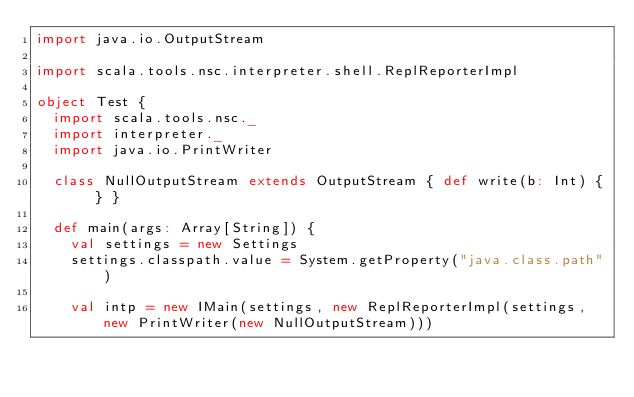Convert code to text. <code><loc_0><loc_0><loc_500><loc_500><_Scala_>import java.io.OutputStream

import scala.tools.nsc.interpreter.shell.ReplReporterImpl

object Test {
  import scala.tools.nsc._
  import interpreter._
  import java.io.PrintWriter

  class NullOutputStream extends OutputStream { def write(b: Int) { } }

  def main(args: Array[String]) {
    val settings = new Settings
    settings.classpath.value = System.getProperty("java.class.path")

    val intp = new IMain(settings, new ReplReporterImpl(settings, new PrintWriter(new NullOutputStream)))</code> 